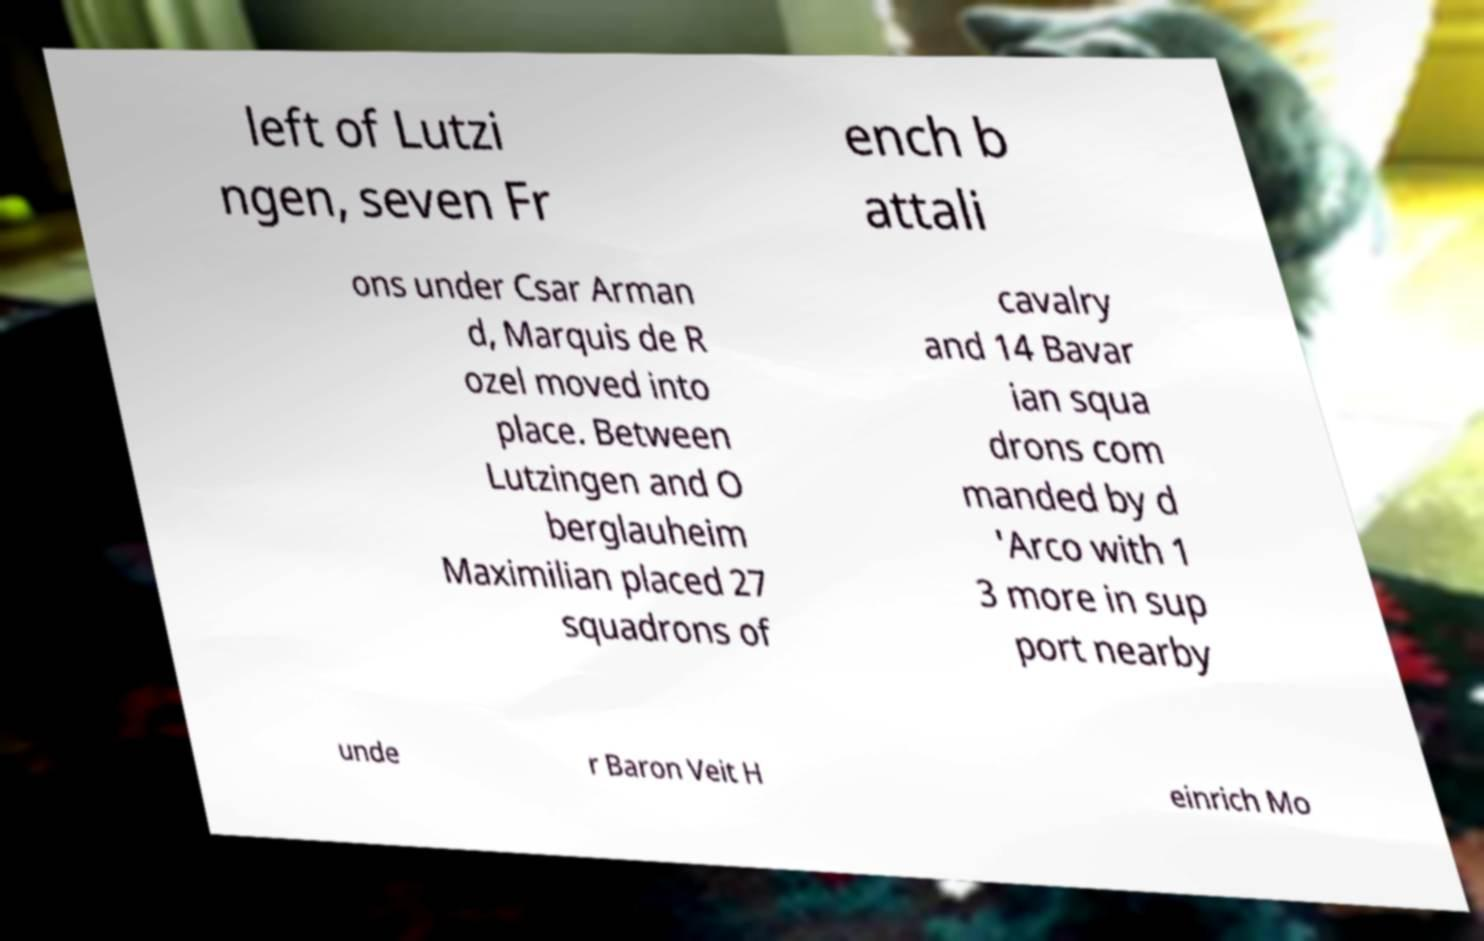There's text embedded in this image that I need extracted. Can you transcribe it verbatim? left of Lutzi ngen, seven Fr ench b attali ons under Csar Arman d, Marquis de R ozel moved into place. Between Lutzingen and O berglauheim Maximilian placed 27 squadrons of cavalry and 14 Bavar ian squa drons com manded by d 'Arco with 1 3 more in sup port nearby unde r Baron Veit H einrich Mo 